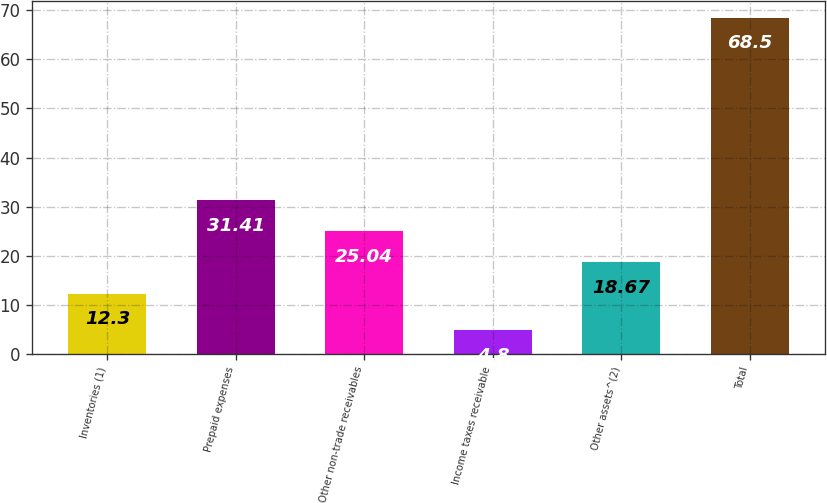Convert chart to OTSL. <chart><loc_0><loc_0><loc_500><loc_500><bar_chart><fcel>Inventories (1)<fcel>Prepaid expenses<fcel>Other non-trade receivables<fcel>Income taxes receivable<fcel>Other assets^(2)<fcel>Total<nl><fcel>12.3<fcel>31.41<fcel>25.04<fcel>4.8<fcel>18.67<fcel>68.5<nl></chart> 